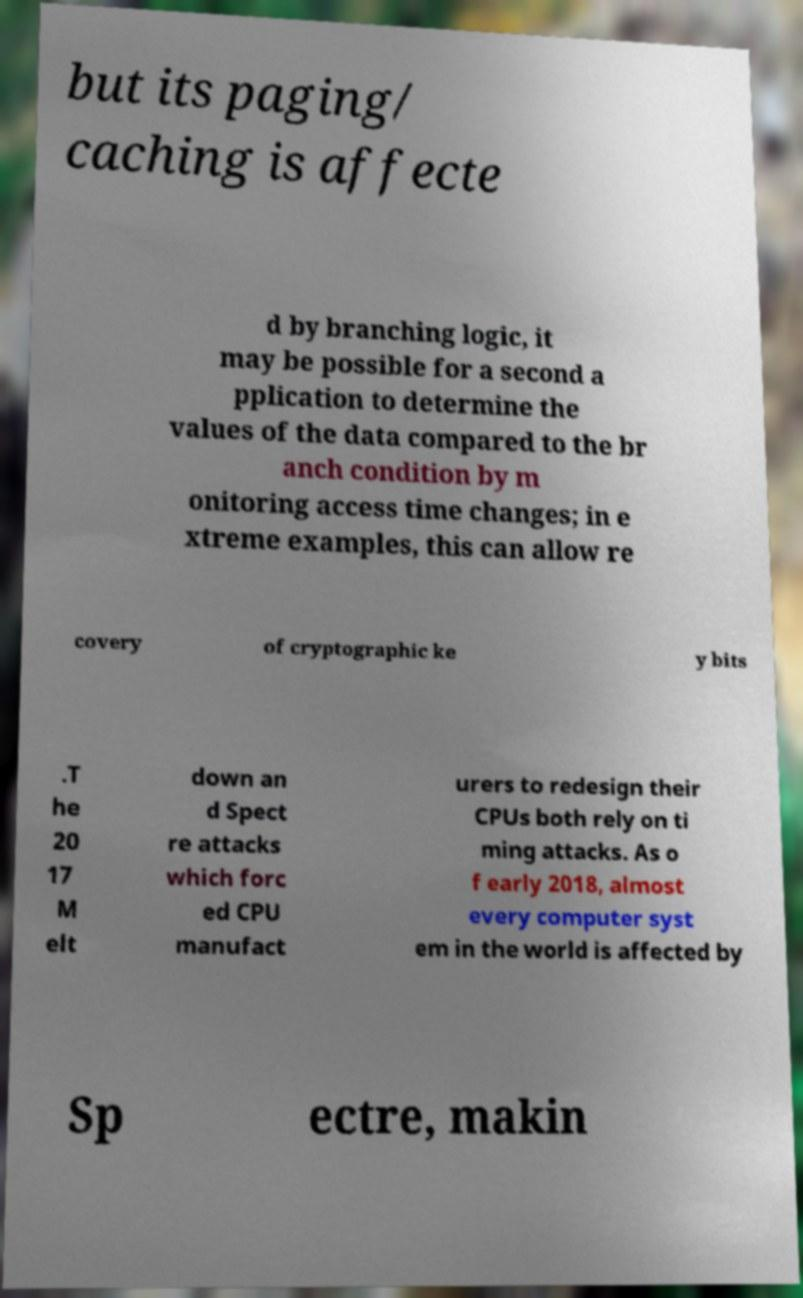I need the written content from this picture converted into text. Can you do that? but its paging/ caching is affecte d by branching logic, it may be possible for a second a pplication to determine the values of the data compared to the br anch condition by m onitoring access time changes; in e xtreme examples, this can allow re covery of cryptographic ke y bits .T he 20 17 M elt down an d Spect re attacks which forc ed CPU manufact urers to redesign their CPUs both rely on ti ming attacks. As o f early 2018, almost every computer syst em in the world is affected by Sp ectre, makin 